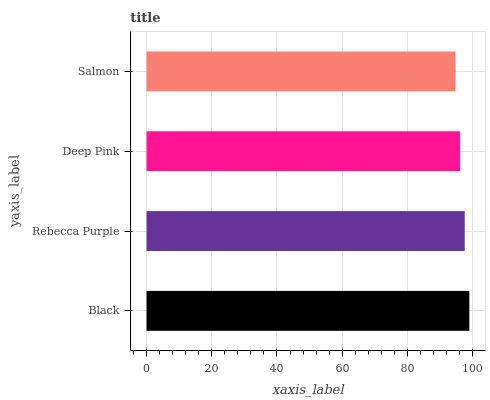Is Salmon the minimum?
Answer yes or no. Yes. Is Black the maximum?
Answer yes or no. Yes. Is Rebecca Purple the minimum?
Answer yes or no. No. Is Rebecca Purple the maximum?
Answer yes or no. No. Is Black greater than Rebecca Purple?
Answer yes or no. Yes. Is Rebecca Purple less than Black?
Answer yes or no. Yes. Is Rebecca Purple greater than Black?
Answer yes or no. No. Is Black less than Rebecca Purple?
Answer yes or no. No. Is Rebecca Purple the high median?
Answer yes or no. Yes. Is Deep Pink the low median?
Answer yes or no. Yes. Is Salmon the high median?
Answer yes or no. No. Is Rebecca Purple the low median?
Answer yes or no. No. 